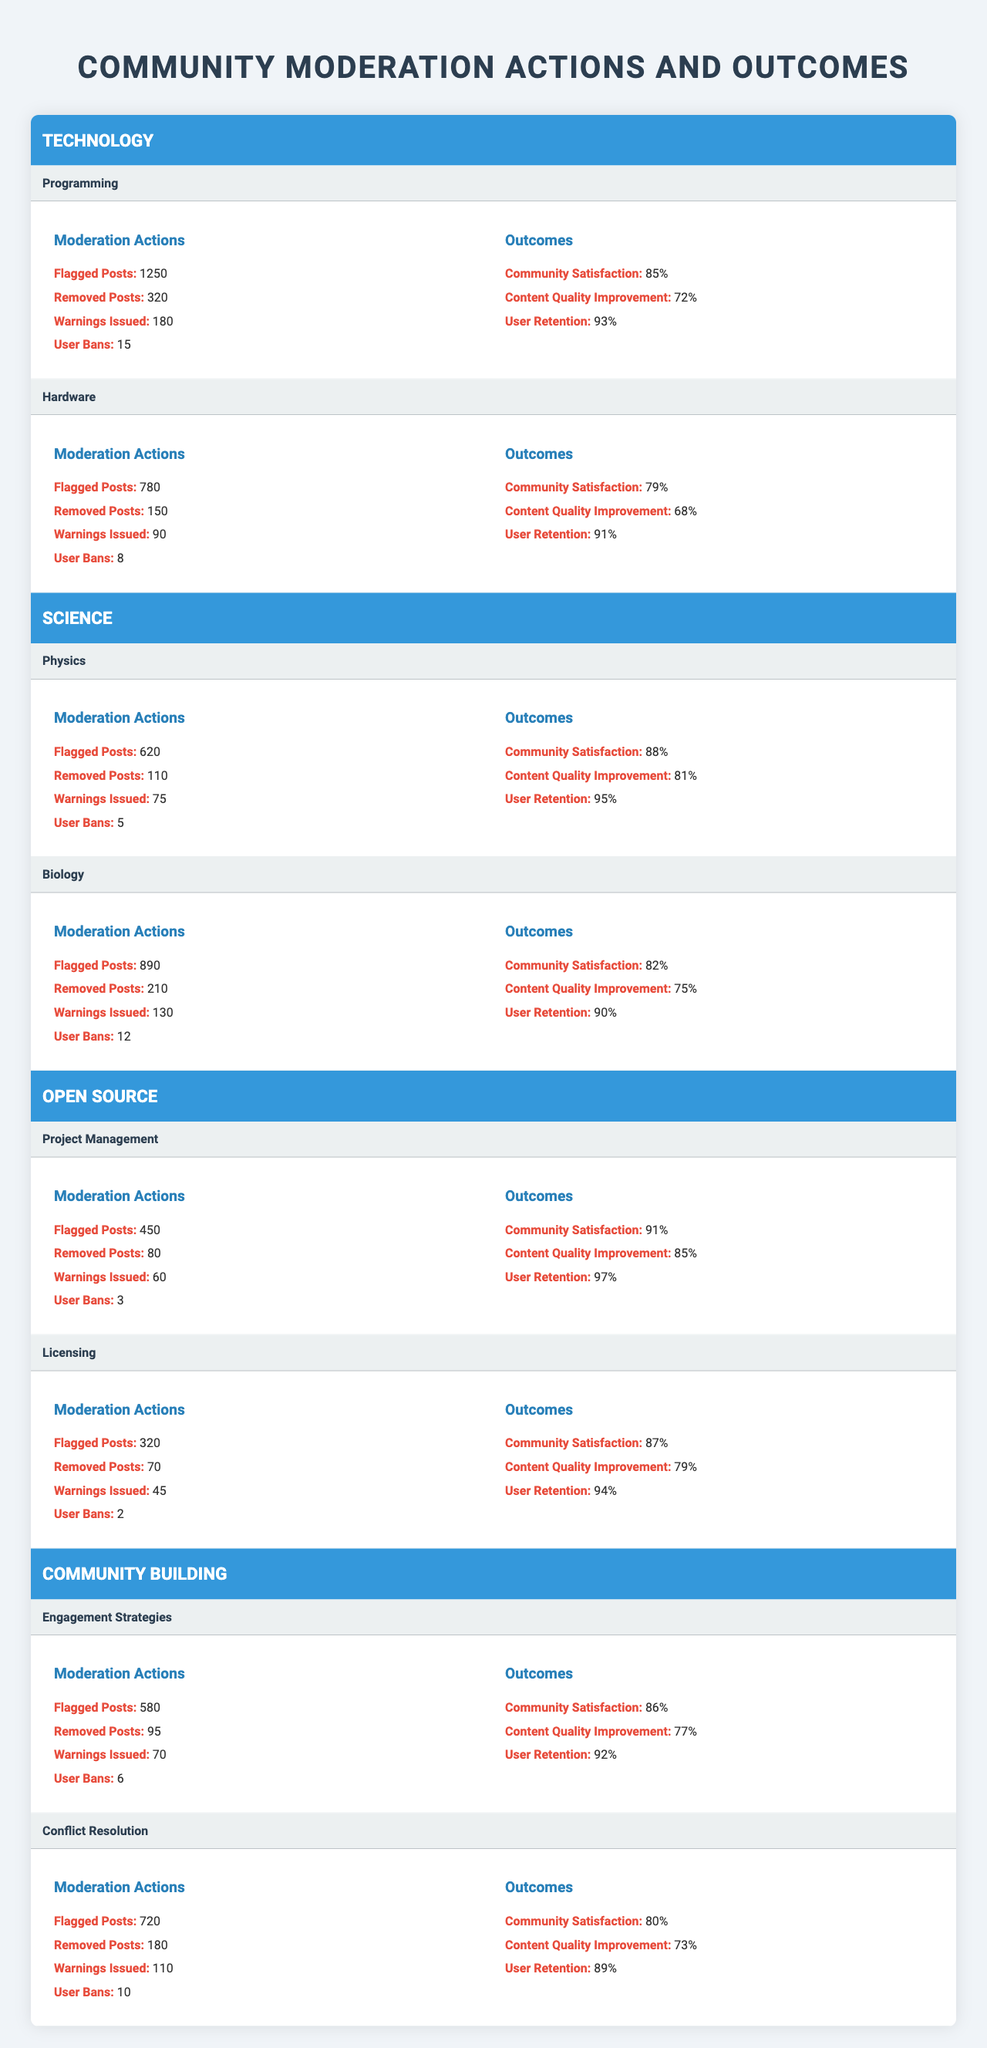What is the total number of flagged posts in the "Science" category? In the "Science" category, there are 620 flagged posts in Physics and 890 flagged posts in Biology. So, the total number of flagged posts is 620 + 890 = 1510.
Answer: 1510 Which subcategory in the "Technology" category has the highest community satisfaction? The subcategory "Programming" has a community satisfaction of 85%, while "Hardware" has 79%. Hence, "Programming" has the highest community satisfaction.
Answer: Programming How many total user bans were issued across all subcategories in the "Open Source" category? In the "Open Source" category, user bans are as follows: Project Management has 3 and Licensing has 2. Therefore, the total user bans is 3 + 2 = 5.
Answer: 5 Is the "Community Satisfaction" higher in "Project Management" than in "Engagement Strategies"? "Project Management" has a community satisfaction of 91% while "Engagement Strategies" has 86%. Since 91% is greater than 86%, the statement is true.
Answer: Yes What is the average content quality improvement percentage across all subcategories? The content quality improvements are: 72% (Programming), 68% (Hardware), 81% (Physics), 75% (Biology), 85% (Project Management), 79% (Licensing), 77% (Engagement Strategies), and 73% (Conflict Resolution). Summing these yields 72 + 68 + 81 + 75 + 85 + 79 + 77 + 73 = 600. Dividing by 8 subcategories gives an average of 600 / 8 = 75%.
Answer: 75% Which subcategory has the lowest user retention rate, and what is that rate? The subcategory with the lowest user retention is "Conflict Resolution" at 89%, compared to others in the community building category.
Answer: Conflict Resolution, 89% Are there more removed posts in "Biology" than in "Programming"? "Biology" has 210 removed posts, while "Programming" has 320. Since 210 is less than 320, the statement is false.
Answer: No What is the difference in the number of warnings issued between "Hardware" and "Conflict Resolution"? "Hardware" issued 90 warnings and "Conflict Resolution" issued 110 warnings. The difference is 110 - 90 = 20 warnings.
Answer: 20 Which category, on average, has better community satisfaction: Open Source or Technology? The average community satisfaction for Open Source is (91% + 87%) / 2 = 89%, while for Technology it is (85% + 79%) / 2 = 82%. Comparing these, Open Source has better satisfaction.
Answer: Open Source How does the user retention in "Licensing" compare to that in "Biology"? The user retention in "Licensing" is 94% while in "Biology" it is 90%. Therefore, Licensing has higher user retention.
Answer: Licensing What percentage of posts were removed out of the total flagged posts in "Programming"? In "Programming", 320 posts were removed out of 1250 flagged posts. The percentage is (320 / 1250) * 100 = 25.6%.
Answer: 25.6% 